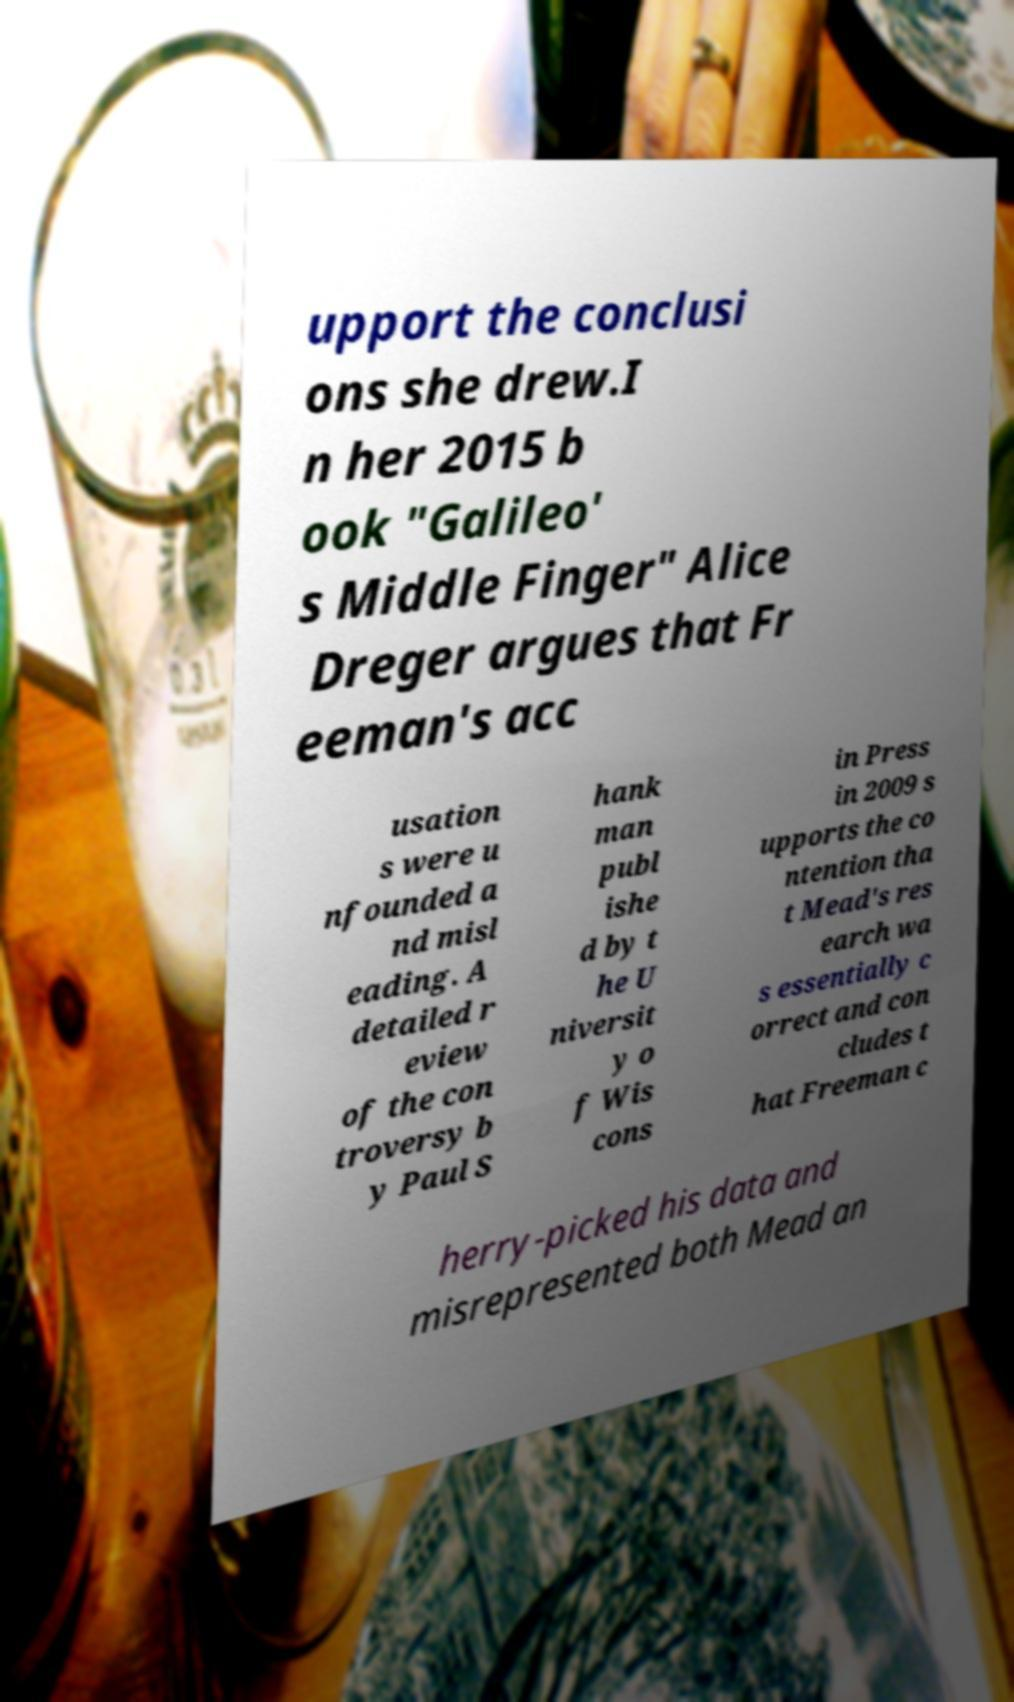Could you extract and type out the text from this image? upport the conclusi ons she drew.I n her 2015 b ook "Galileo' s Middle Finger" Alice Dreger argues that Fr eeman's acc usation s were u nfounded a nd misl eading. A detailed r eview of the con troversy b y Paul S hank man publ ishe d by t he U niversit y o f Wis cons in Press in 2009 s upports the co ntention tha t Mead's res earch wa s essentially c orrect and con cludes t hat Freeman c herry-picked his data and misrepresented both Mead an 